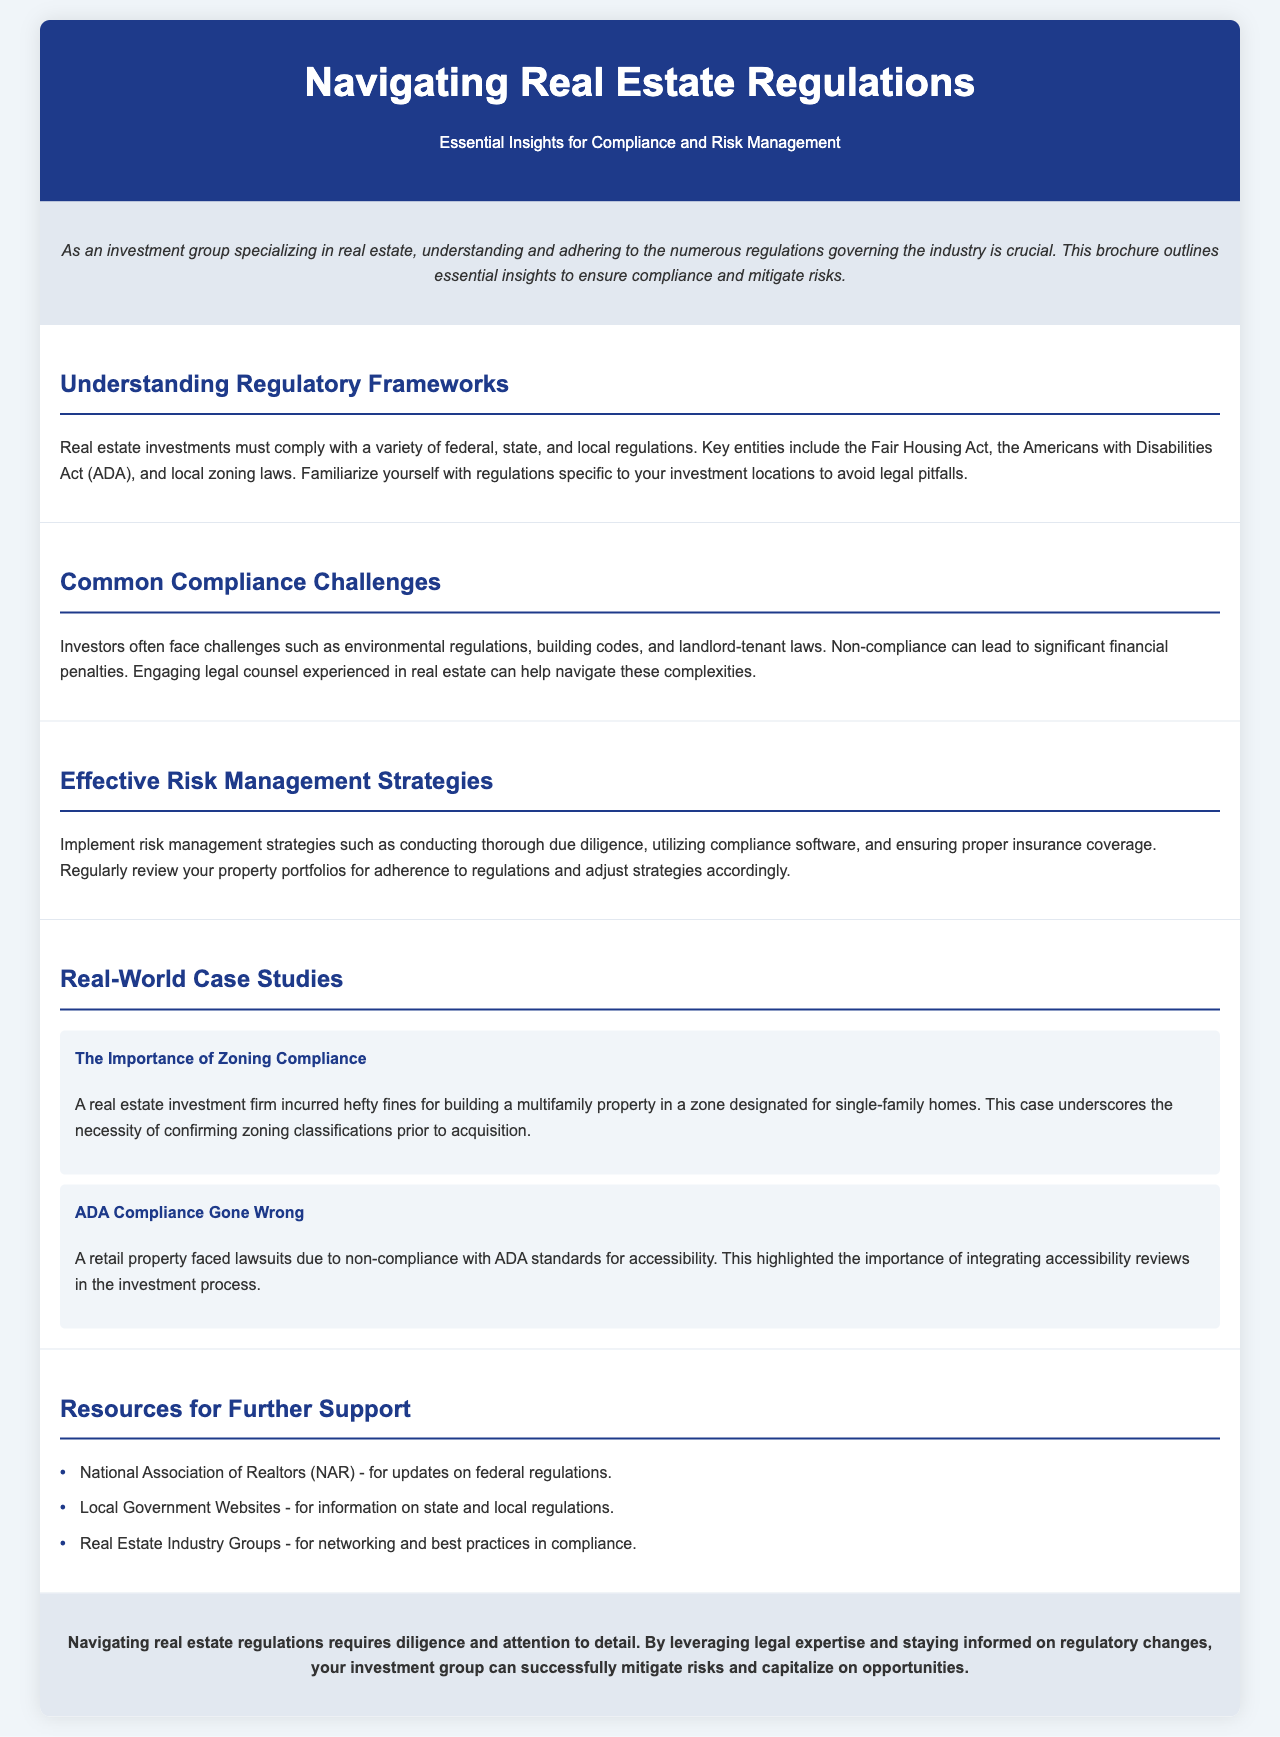What is the main focus of the brochure? The brochure focuses on providing essential insights for compliance and risk management in real estate investments.
Answer: Compliance and risk management Who authored the Fair Housing Act? The document mentions the Fair Housing Act as an important regulation but does not specify its author.
Answer: Not specified What type of laws do investors need to familiarize themselves with? Investors need to familiarize themselves with regulations specific to their investment locations to avoid legal pitfalls.
Answer: Zoning laws What is one common challenge mentioned for investors? The document lists multiple compliance challenges, including environmental regulations.
Answer: Environmental regulations What are two effective risk management strategies suggested? The strategies include conducting thorough due diligence and utilizing compliance software.
Answer: Due diligence, compliance software What can non-compliance with regulations lead to? The document states that non-compliance can lead to significant financial penalties.
Answer: Financial penalties What should be integrated into the investment process to avoid lawsuits? The document highlights the importance of integrating accessibility reviews to avoid lawsuits.
Answer: Accessibility reviews Which organization can provide updates on federal regulations? The brochure mentions the National Association of Realtors (NAR) as a resource for updates.
Answer: National Association of Realtors (NAR) What is emphasized as crucial for navigating real estate regulations? The document emphasizes that diligence and attention to detail are crucial for navigating real estate regulations.
Answer: Diligence and attention to detail 